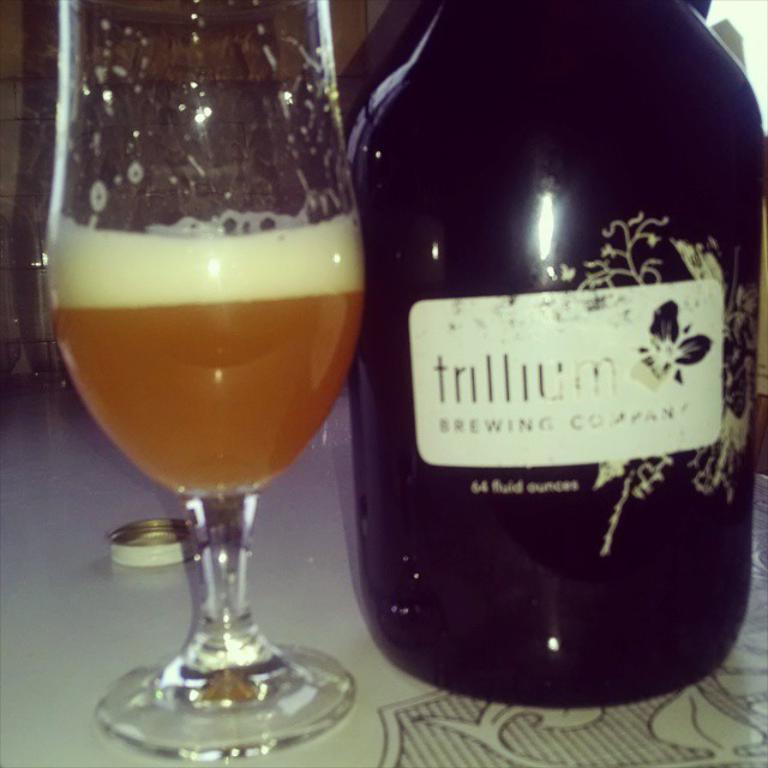How many fluid ounces?
Make the answer very short. 64. 